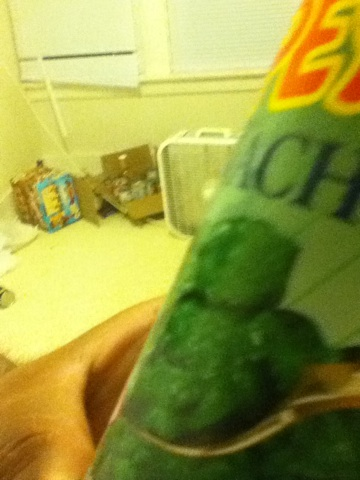What are the nutritional benefits of consuming spinach? Spinach is an excellent source of vitamins A, C, and K, as well as minerals like iron and manganese. It's also rich in antioxidants and is a great choice for a healthy diet. 